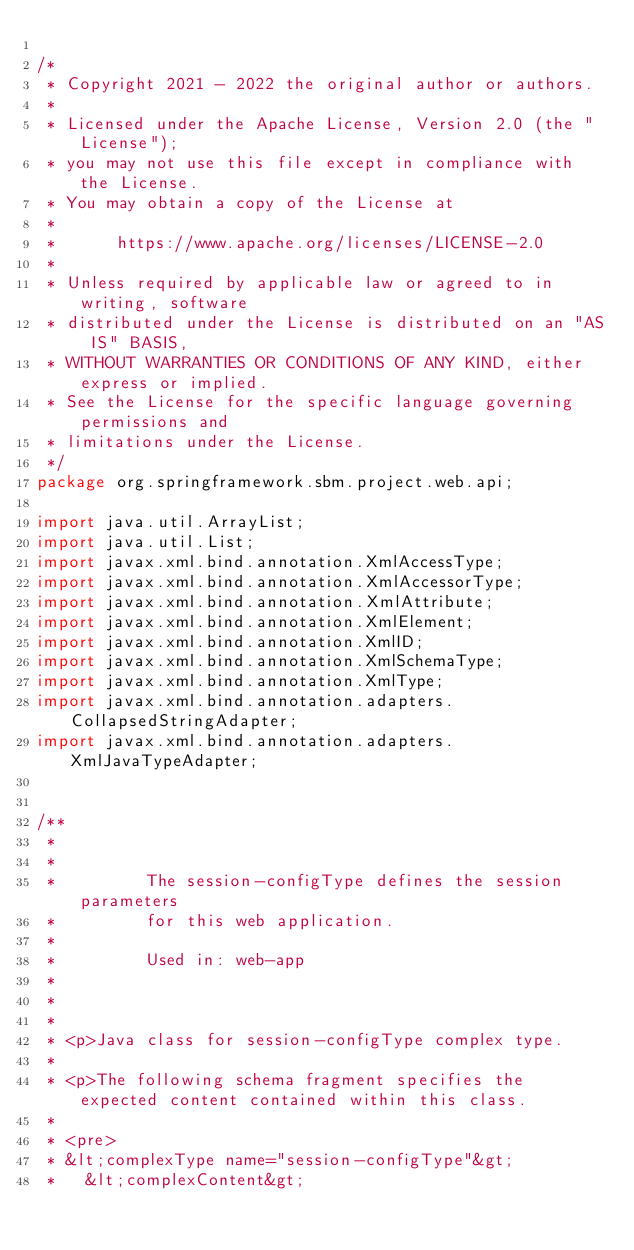<code> <loc_0><loc_0><loc_500><loc_500><_Java_>
/*
 * Copyright 2021 - 2022 the original author or authors.
 *
 * Licensed under the Apache License, Version 2.0 (the "License");
 * you may not use this file except in compliance with the License.
 * You may obtain a copy of the License at
 *
 *      https://www.apache.org/licenses/LICENSE-2.0
 *
 * Unless required by applicable law or agreed to in writing, software
 * distributed under the License is distributed on an "AS IS" BASIS,
 * WITHOUT WARRANTIES OR CONDITIONS OF ANY KIND, either express or implied.
 * See the License for the specific language governing permissions and
 * limitations under the License.
 */
package org.springframework.sbm.project.web.api;

import java.util.ArrayList;
import java.util.List;
import javax.xml.bind.annotation.XmlAccessType;
import javax.xml.bind.annotation.XmlAccessorType;
import javax.xml.bind.annotation.XmlAttribute;
import javax.xml.bind.annotation.XmlElement;
import javax.xml.bind.annotation.XmlID;
import javax.xml.bind.annotation.XmlSchemaType;
import javax.xml.bind.annotation.XmlType;
import javax.xml.bind.annotation.adapters.CollapsedStringAdapter;
import javax.xml.bind.annotation.adapters.XmlJavaTypeAdapter;


/**
 * 
 * 
 *         The session-configType defines the session parameters
 *         for this web application.
 *         
 *         Used in: web-app
 *         
 *       
 * 
 * <p>Java class for session-configType complex type.
 * 
 * <p>The following schema fragment specifies the expected content contained within this class.
 * 
 * <pre>
 * &lt;complexType name="session-configType"&gt;
 *   &lt;complexContent&gt;</code> 